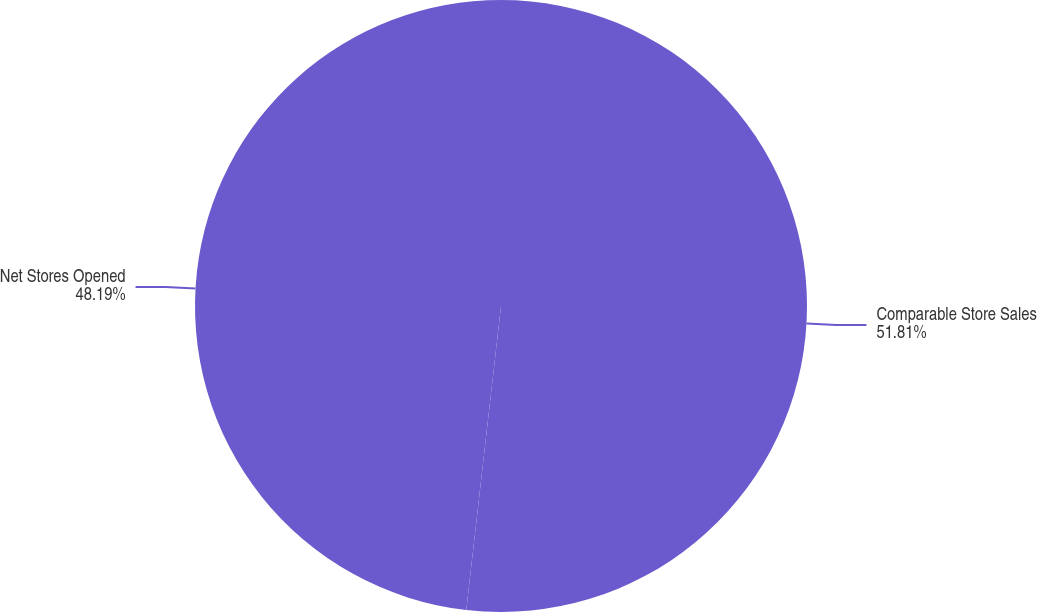<chart> <loc_0><loc_0><loc_500><loc_500><pie_chart><fcel>Comparable Store Sales<fcel>Net Stores Opened<nl><fcel>51.81%<fcel>48.19%<nl></chart> 